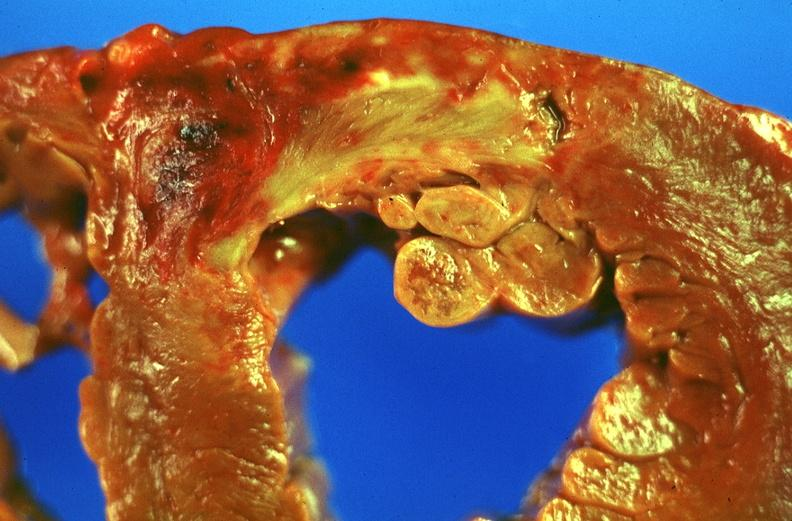where is this?
Answer the question using a single word or phrase. Heart 